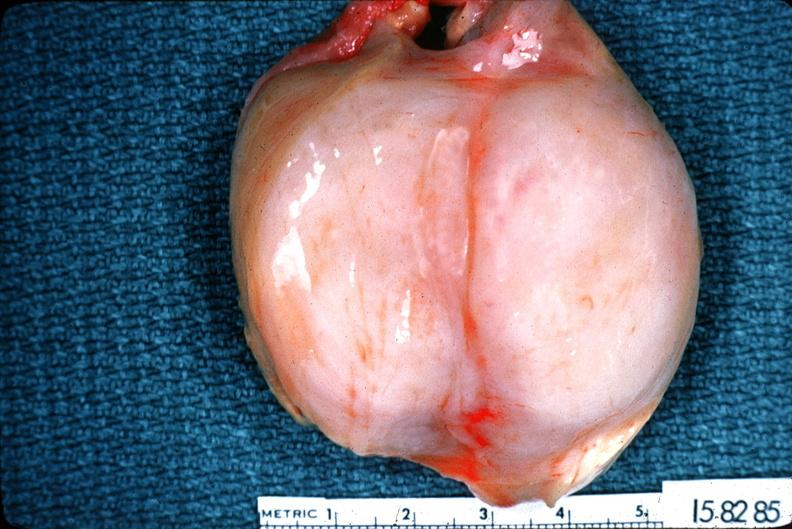s opened bladder with median lobe protruding into trigone area also present?
Answer the question using a single word or phrase. No 